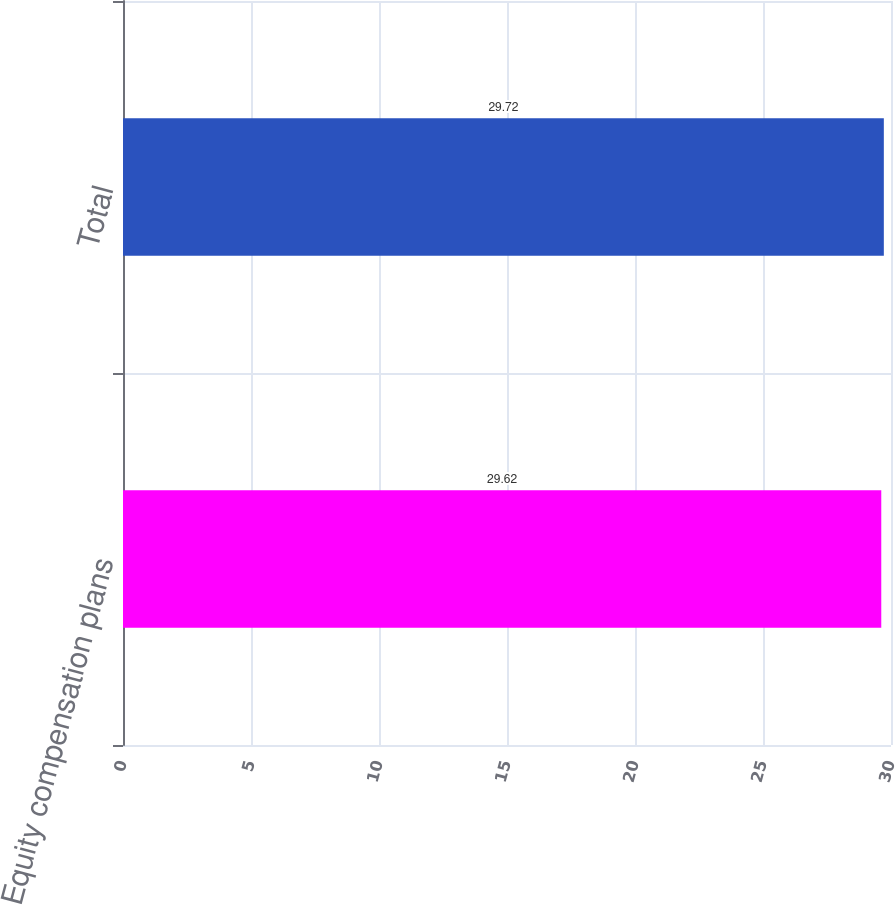<chart> <loc_0><loc_0><loc_500><loc_500><bar_chart><fcel>Equity compensation plans<fcel>Total<nl><fcel>29.62<fcel>29.72<nl></chart> 